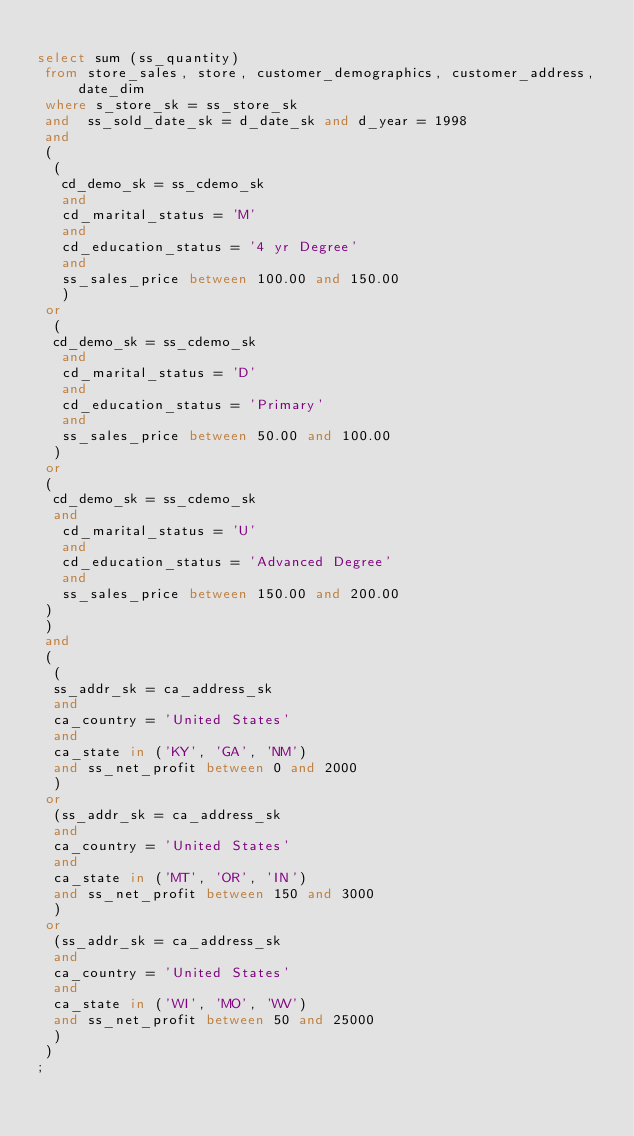<code> <loc_0><loc_0><loc_500><loc_500><_SQL_>
select sum (ss_quantity)
 from store_sales, store, customer_demographics, customer_address, date_dim
 where s_store_sk = ss_store_sk
 and  ss_sold_date_sk = d_date_sk and d_year = 1998
 and  
 (
  (
   cd_demo_sk = ss_cdemo_sk
   and 
   cd_marital_status = 'M'
   and 
   cd_education_status = '4 yr Degree'
   and 
   ss_sales_price between 100.00 and 150.00  
   )
 or
  (
  cd_demo_sk = ss_cdemo_sk
   and 
   cd_marital_status = 'D'
   and 
   cd_education_status = 'Primary'
   and 
   ss_sales_price between 50.00 and 100.00   
  )
 or 
 (
  cd_demo_sk = ss_cdemo_sk
  and 
   cd_marital_status = 'U'
   and 
   cd_education_status = 'Advanced Degree'
   and 
   ss_sales_price between 150.00 and 200.00  
 )
 )
 and
 (
  (
  ss_addr_sk = ca_address_sk
  and
  ca_country = 'United States'
  and
  ca_state in ('KY', 'GA', 'NM')
  and ss_net_profit between 0 and 2000  
  )
 or
  (ss_addr_sk = ca_address_sk
  and
  ca_country = 'United States'
  and
  ca_state in ('MT', 'OR', 'IN')
  and ss_net_profit between 150 and 3000 
  )
 or
  (ss_addr_sk = ca_address_sk
  and
  ca_country = 'United States'
  and
  ca_state in ('WI', 'MO', 'WV')
  and ss_net_profit between 50 and 25000 
  )
 )
;


</code> 